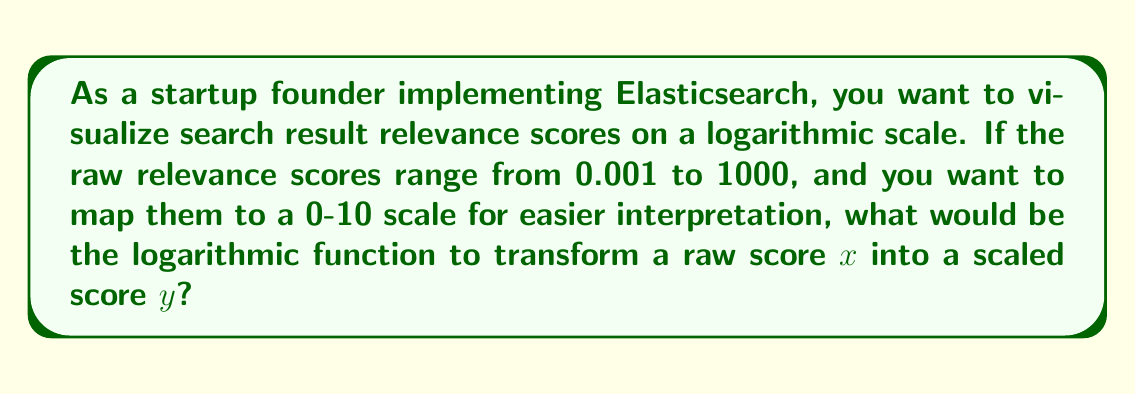Show me your answer to this math problem. To map the raw scores to a logarithmic scale, we'll use the following approach:

1) First, we need to identify the range of the log-transformed scores:
   $\log(0.001) \approx -6.91$ and $\log(1000) = 3$

2) We want to map this range to a 0-10 scale. The general form of our function will be:
   $y = a \log(x) + b$

3) We can set up two equations using the minimum and maximum values:
   $0 = a \log(0.001) + b$
   $10 = a \log(1000) + b$

4) Subtracting these equations:
   $10 = a(\log(1000) - \log(0.001))$
   $10 = a(3 - (-6.91)) = 9.91a$

5) Solving for $a$:
   $a = \frac{10}{9.91} \approx 1.009$

6) We can now solve for $b$ using either of the original equations:
   $0 = 1.009 \log(0.001) + b$
   $b = -1.009 \log(0.001) \approx 6.97$

7) Our final function is:
   $y = 1.009 \log(x) + 6.97$

8) To ensure our function works correctly:
   For $x = 0.001$: $y = 1.009 \log(0.001) + 6.97 \approx 0$
   For $x = 1000$: $y = 1.009 \log(1000) + 6.97 \approx 10$
Answer: The logarithmic function to transform a raw score $x$ into a scaled score $y$ is:

$$y = 1.009 \log(x) + 6.97$$

where $\log$ is the natural logarithm. 